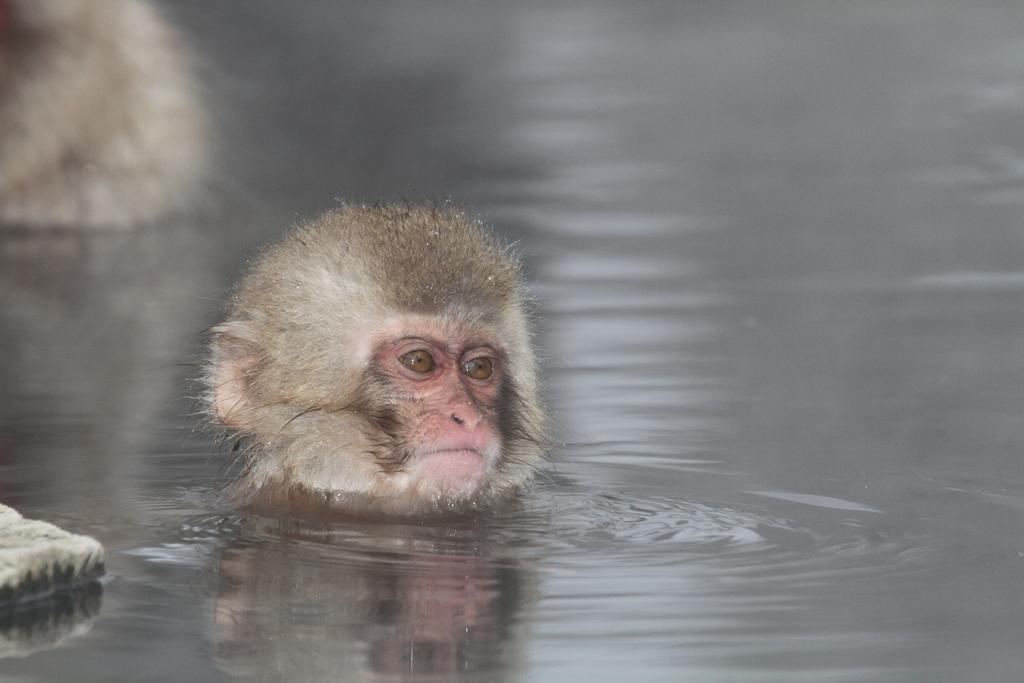What animal is present in the image? There is a monkey in the image. Where is the monkey located in the image? The monkey is in the water. What type of tooth is visible in the image? There is no tooth visible in the image; it features a monkey in the water. 